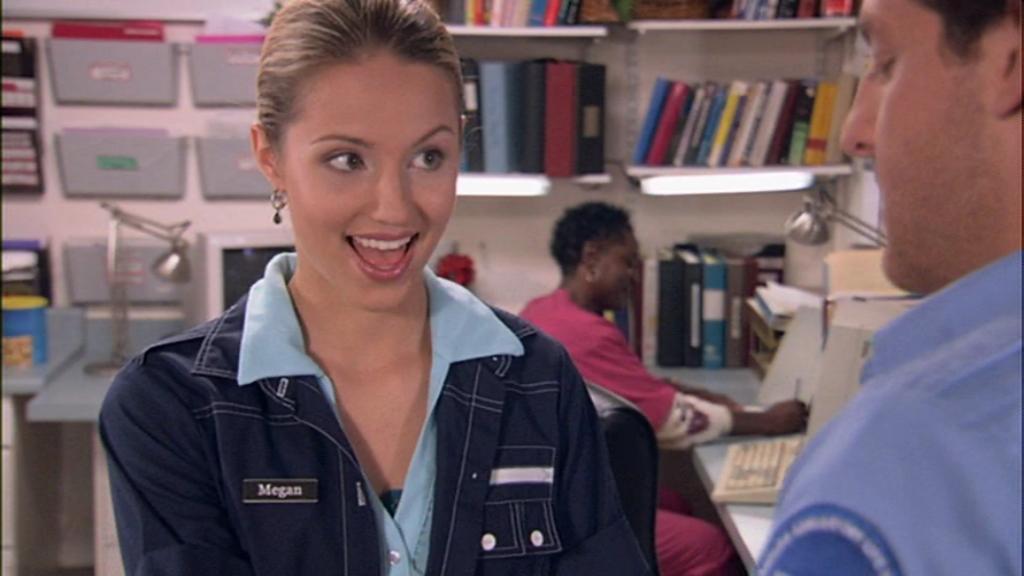Can you describe this image briefly? This is the woman standing and smiling. Here is another woman sitting. These are the books, which are placed in the racks. I can see a study lamp, monitor, keyboard and few other objects are placed on the table. On the right side of the image, I can see a person standing. 